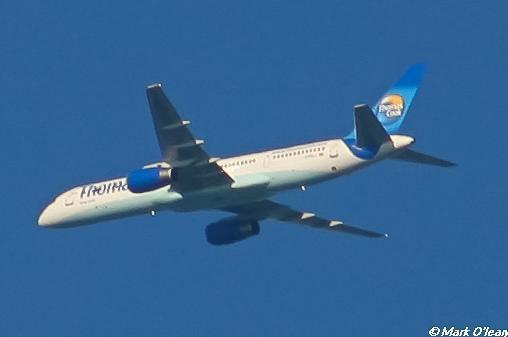How many people are wearing a hat?
Give a very brief answer. 0. 